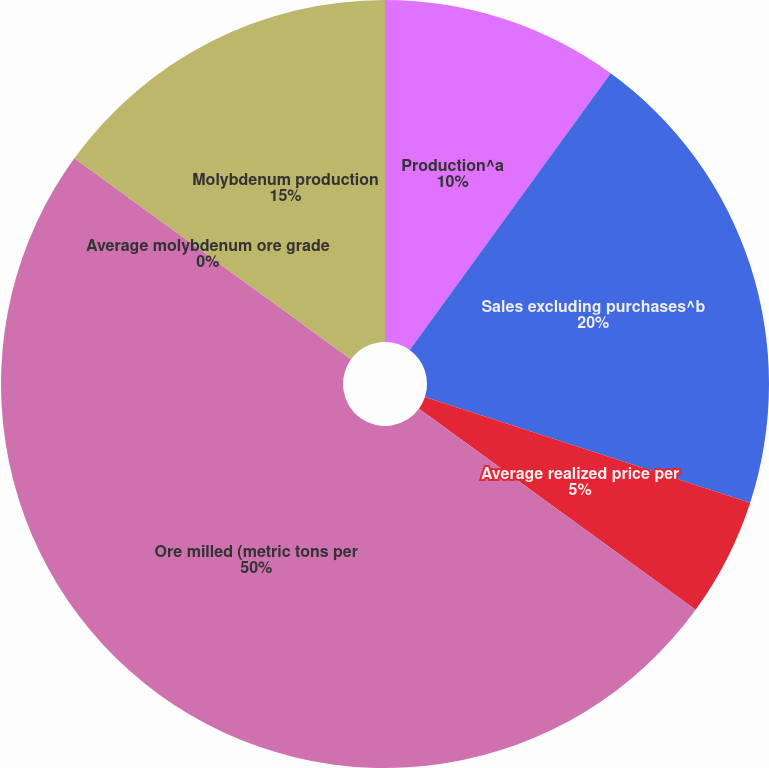Convert chart. <chart><loc_0><loc_0><loc_500><loc_500><pie_chart><fcel>Production^a<fcel>Sales excluding purchases^b<fcel>Average realized price per<fcel>Ore milled (metric tons per<fcel>Average molybdenum ore grade<fcel>Molybdenum production<nl><fcel>10.0%<fcel>20.0%<fcel>5.0%<fcel>50.0%<fcel>0.0%<fcel>15.0%<nl></chart> 